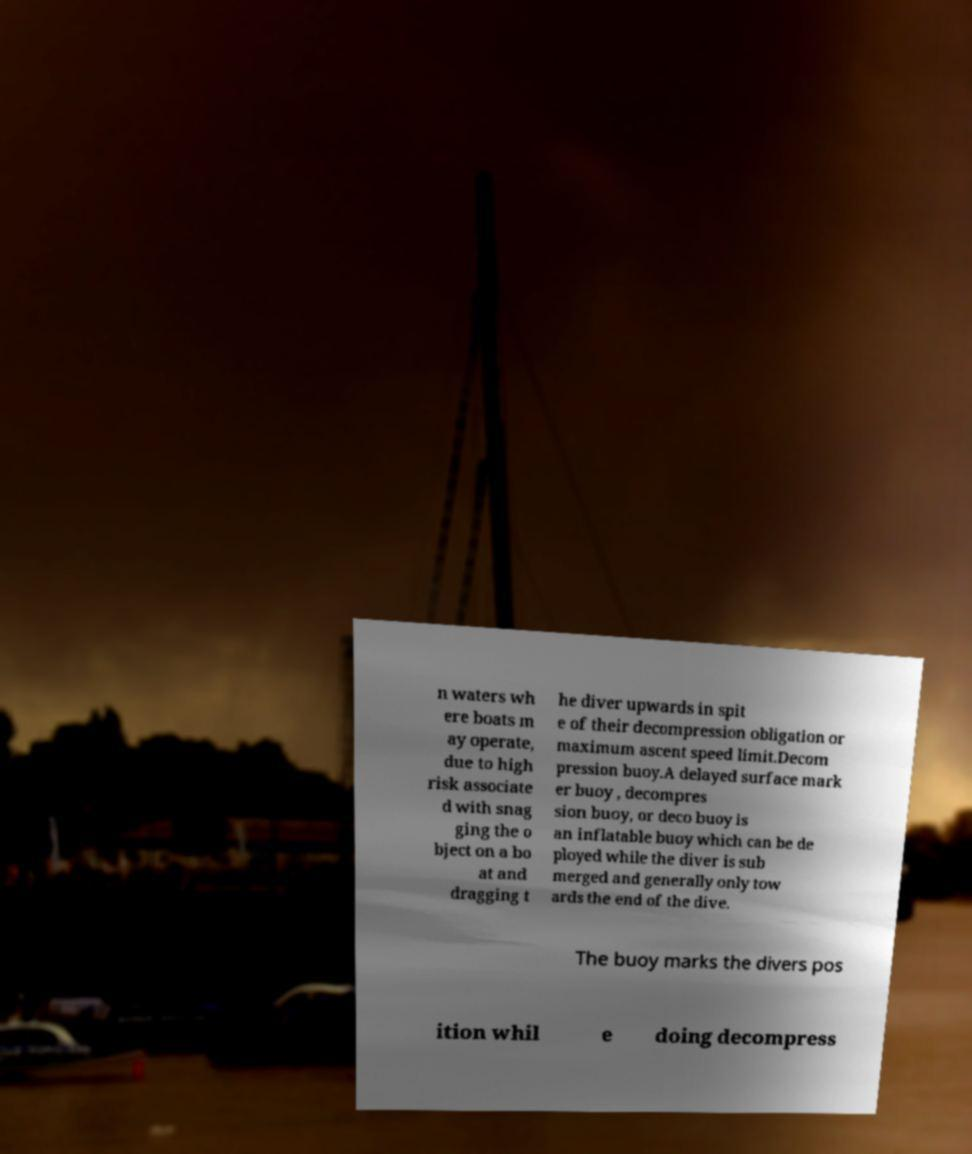Could you extract and type out the text from this image? n waters wh ere boats m ay operate, due to high risk associate d with snag ging the o bject on a bo at and dragging t he diver upwards in spit e of their decompression obligation or maximum ascent speed limit.Decom pression buoy.A delayed surface mark er buoy , decompres sion buoy, or deco buoy is an inflatable buoy which can be de ployed while the diver is sub merged and generally only tow ards the end of the dive. The buoy marks the divers pos ition whil e doing decompress 